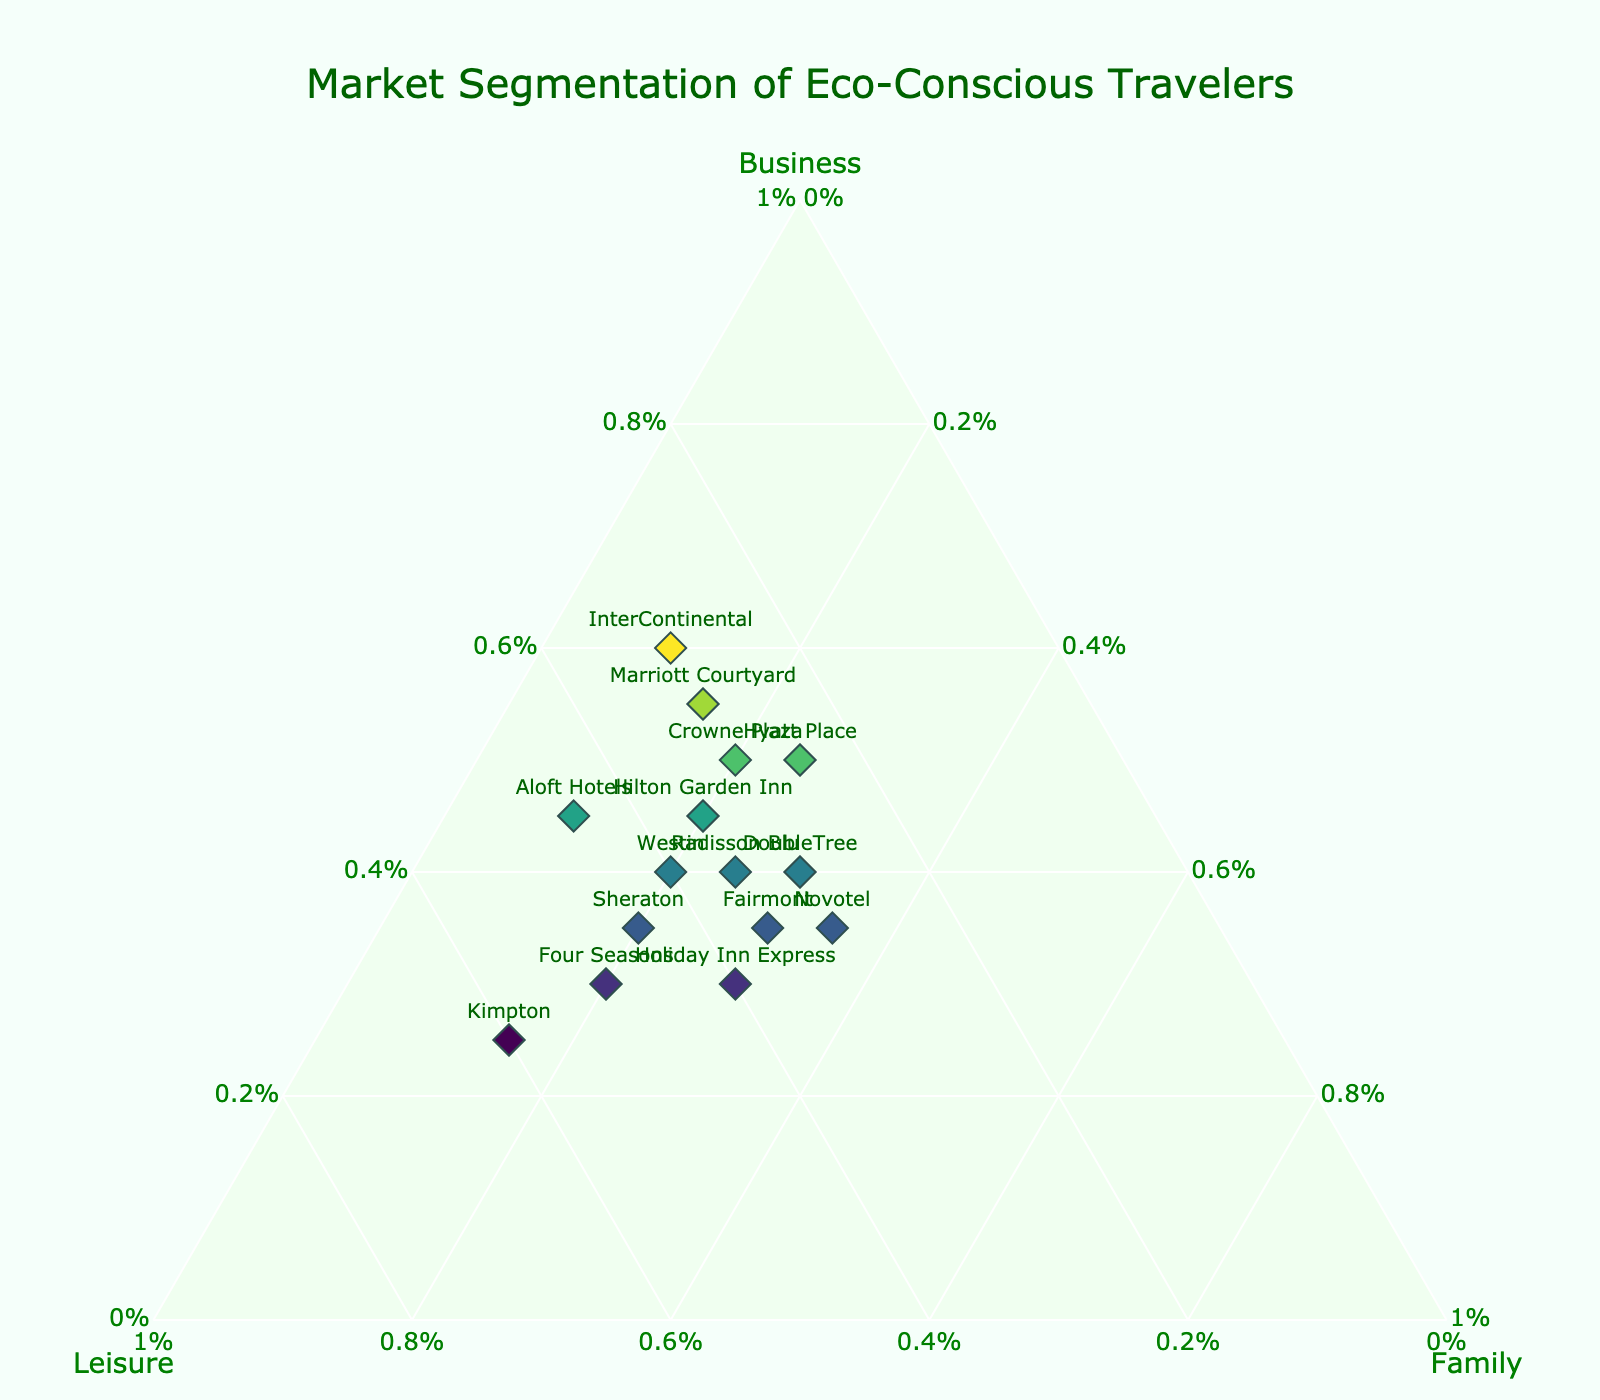What's the title of the plot? The title of the plot is displayed at the top center in larger font size and colored dark green.
Answer: Market Segmentation of Eco-Conscious Travelers How many hotels have a higher proportion of business travelers than leisure travelers? To find this, identify data points where the business proportion is greater than the leisure proportion by comparing the values for each hotel. Hilton Garden Inn, Marriott Courtyard, Hyatt Place, InterContinental, Crowne Plaza, and DoubleTree fit this criterion.
Answer: 6 Which hotel has the largest proportion of family travelers? Examine the 'Family' axis and identify the hotel with the highest value. Novotel has the maximum percentage of family travelers at 35%.
Answer: Novotel What's the overall balance between the three segments in Westin? Look for the plotted point marked 'Westin' and check the values for business, leisure, and family segments; Westin has equal parts leisure (40%) and family (20%) travelers, indicating a balanced segmentation between these markets.
Answer: 40% Business, 40% Leisure, 20% Family Which hotel has the least proportion of family travelers? Look for the point on the plot with the smallest percentage on the 'Family' axis. Both InterContinental and Aloft Hotels have the lowest proportion of family travelers at 10%.
Answer: InterContinental and Aloft Hotels Compare InterContinental and Holiday Inn Express in terms of their traveler segments. Analyze the segments for both hotels:
InterContinental: 60% Business, 30% Leisure, 10% Family 
Holiday Inn Express: 30% Business, 40% Leisure, 30% Family. InterContinental has a higher business segment while Holiday Inn Express has a more balanced leisure and family segment.
Answer: InterContinental is focused on business travelers whereas Holiday Inn Express has a balanced segmentation What’s the average percentage of business travelers across all hotels? Sum up the business percentages and divide by the number of hotels. The sum is 45+55+50+60+40+35+30+45+25+35+40+30+35+50+40 = 615. There are 15 hotels, so the average is 615/15 = 41%.
Answer: 41% Which hotel has an equal proportion of leisure and family travelers? Look for data points where the values for leisure and family are the same. Holiday Inn Express and DoubleTree both have 30% leisure and 30% family travelers.
Answer: Holiday Inn Express and DoubleTree What's the combined proportion of non-business segments for Marriott Courtyard? Identify the proportions of leisure and family for Marriott Courtyard and sum them up: 30% (leisure) + 15% (family) = 45%.
Answer: 45% How many hotels have a leisure segment proportion of at least 50%? Examine the plotted points to find those with leisure proportions of 50% or more. Kimpton and Four Seasons fall in this category, with Kimpton at 60% and Four Seasons at 50%.
Answer: 2 